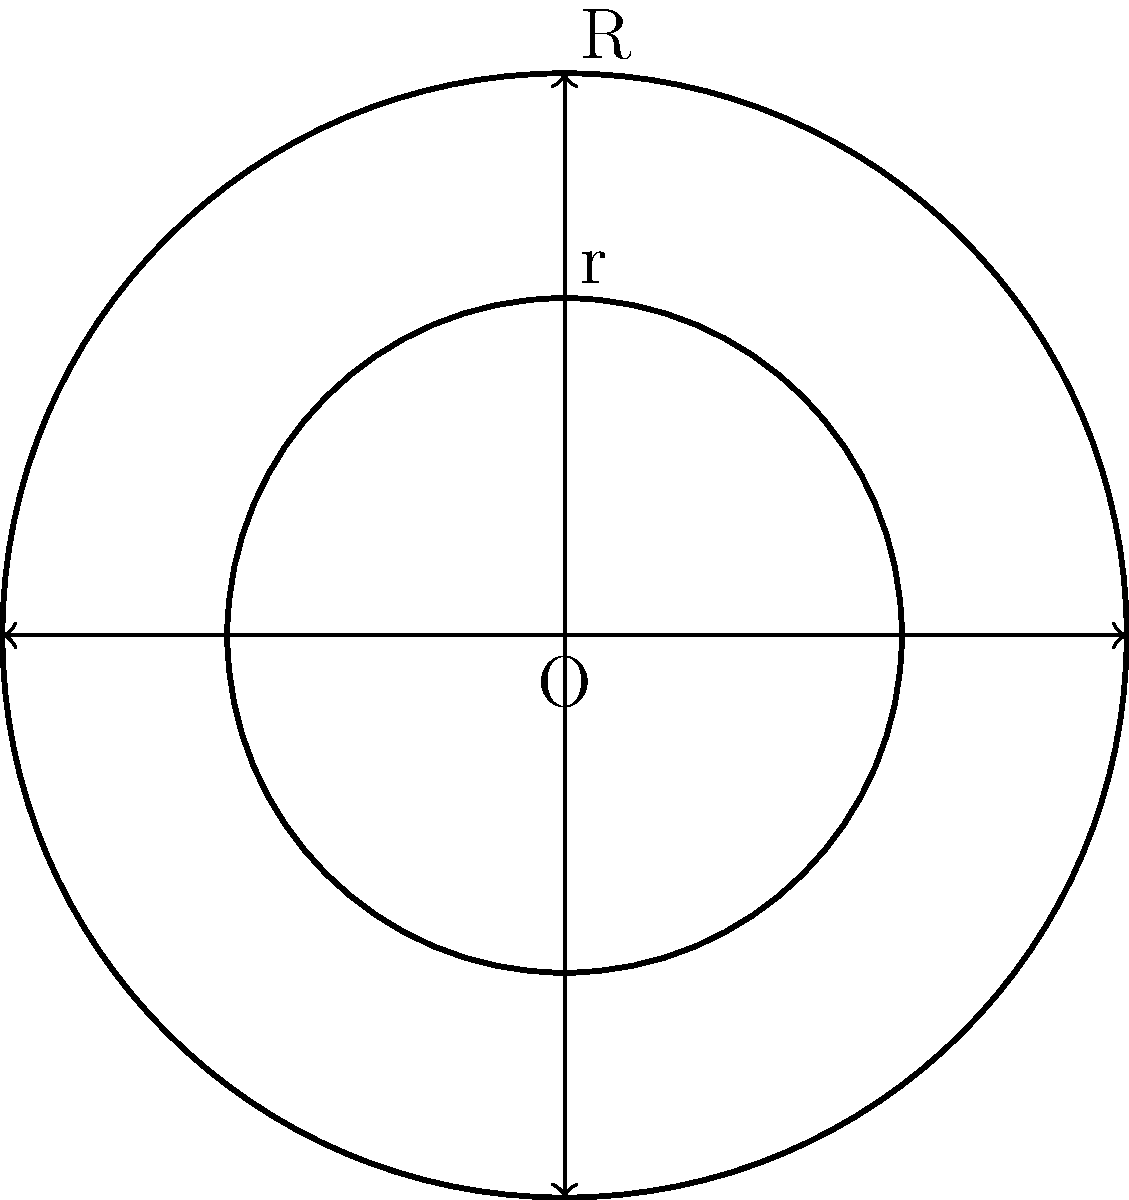The circular logo on a Real Madrid jersey consists of two concentric circles. The outer circle has a radius of 5 cm, and the inner circle has a radius of 3 cm. What is the area of the white region between the two circles? To find the area of the white region between the two circles, we need to:

1. Calculate the area of the larger circle (outer circle):
   $$A_1 = \pi R^2 = \pi (5 \text{ cm})^2 = 25\pi \text{ cm}^2$$

2. Calculate the area of the smaller circle (inner circle):
   $$A_2 = \pi r^2 = \pi (3 \text{ cm})^2 = 9\pi \text{ cm}^2$$

3. Subtract the area of the smaller circle from the area of the larger circle:
   $$A_{\text{white}} = A_1 - A_2 = 25\pi \text{ cm}^2 - 9\pi \text{ cm}^2 = 16\pi \text{ cm}^2$$

Therefore, the area of the white region between the two circles is $16\pi \text{ cm}^2$.
Answer: $16\pi \text{ cm}^2$ 